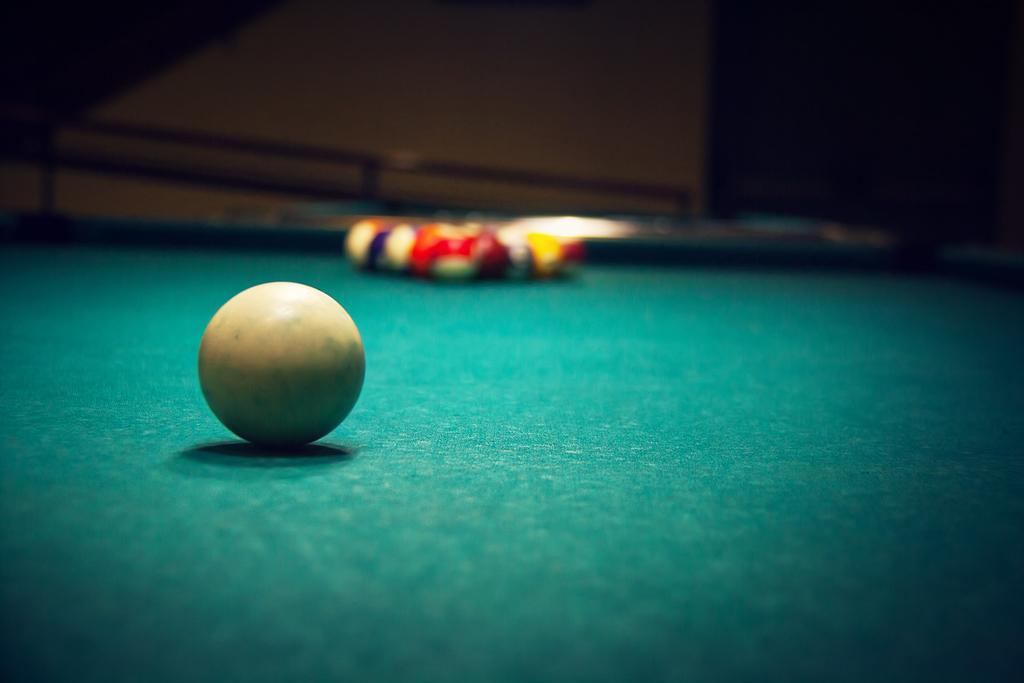What type of table is in the image? There is a billiard table in the image. What is on top of the table? There are billiard balls on the table. What type of basket is hanging on the wall in the image? There is no basket present in the image; it only features a billiard table and billiard balls. 